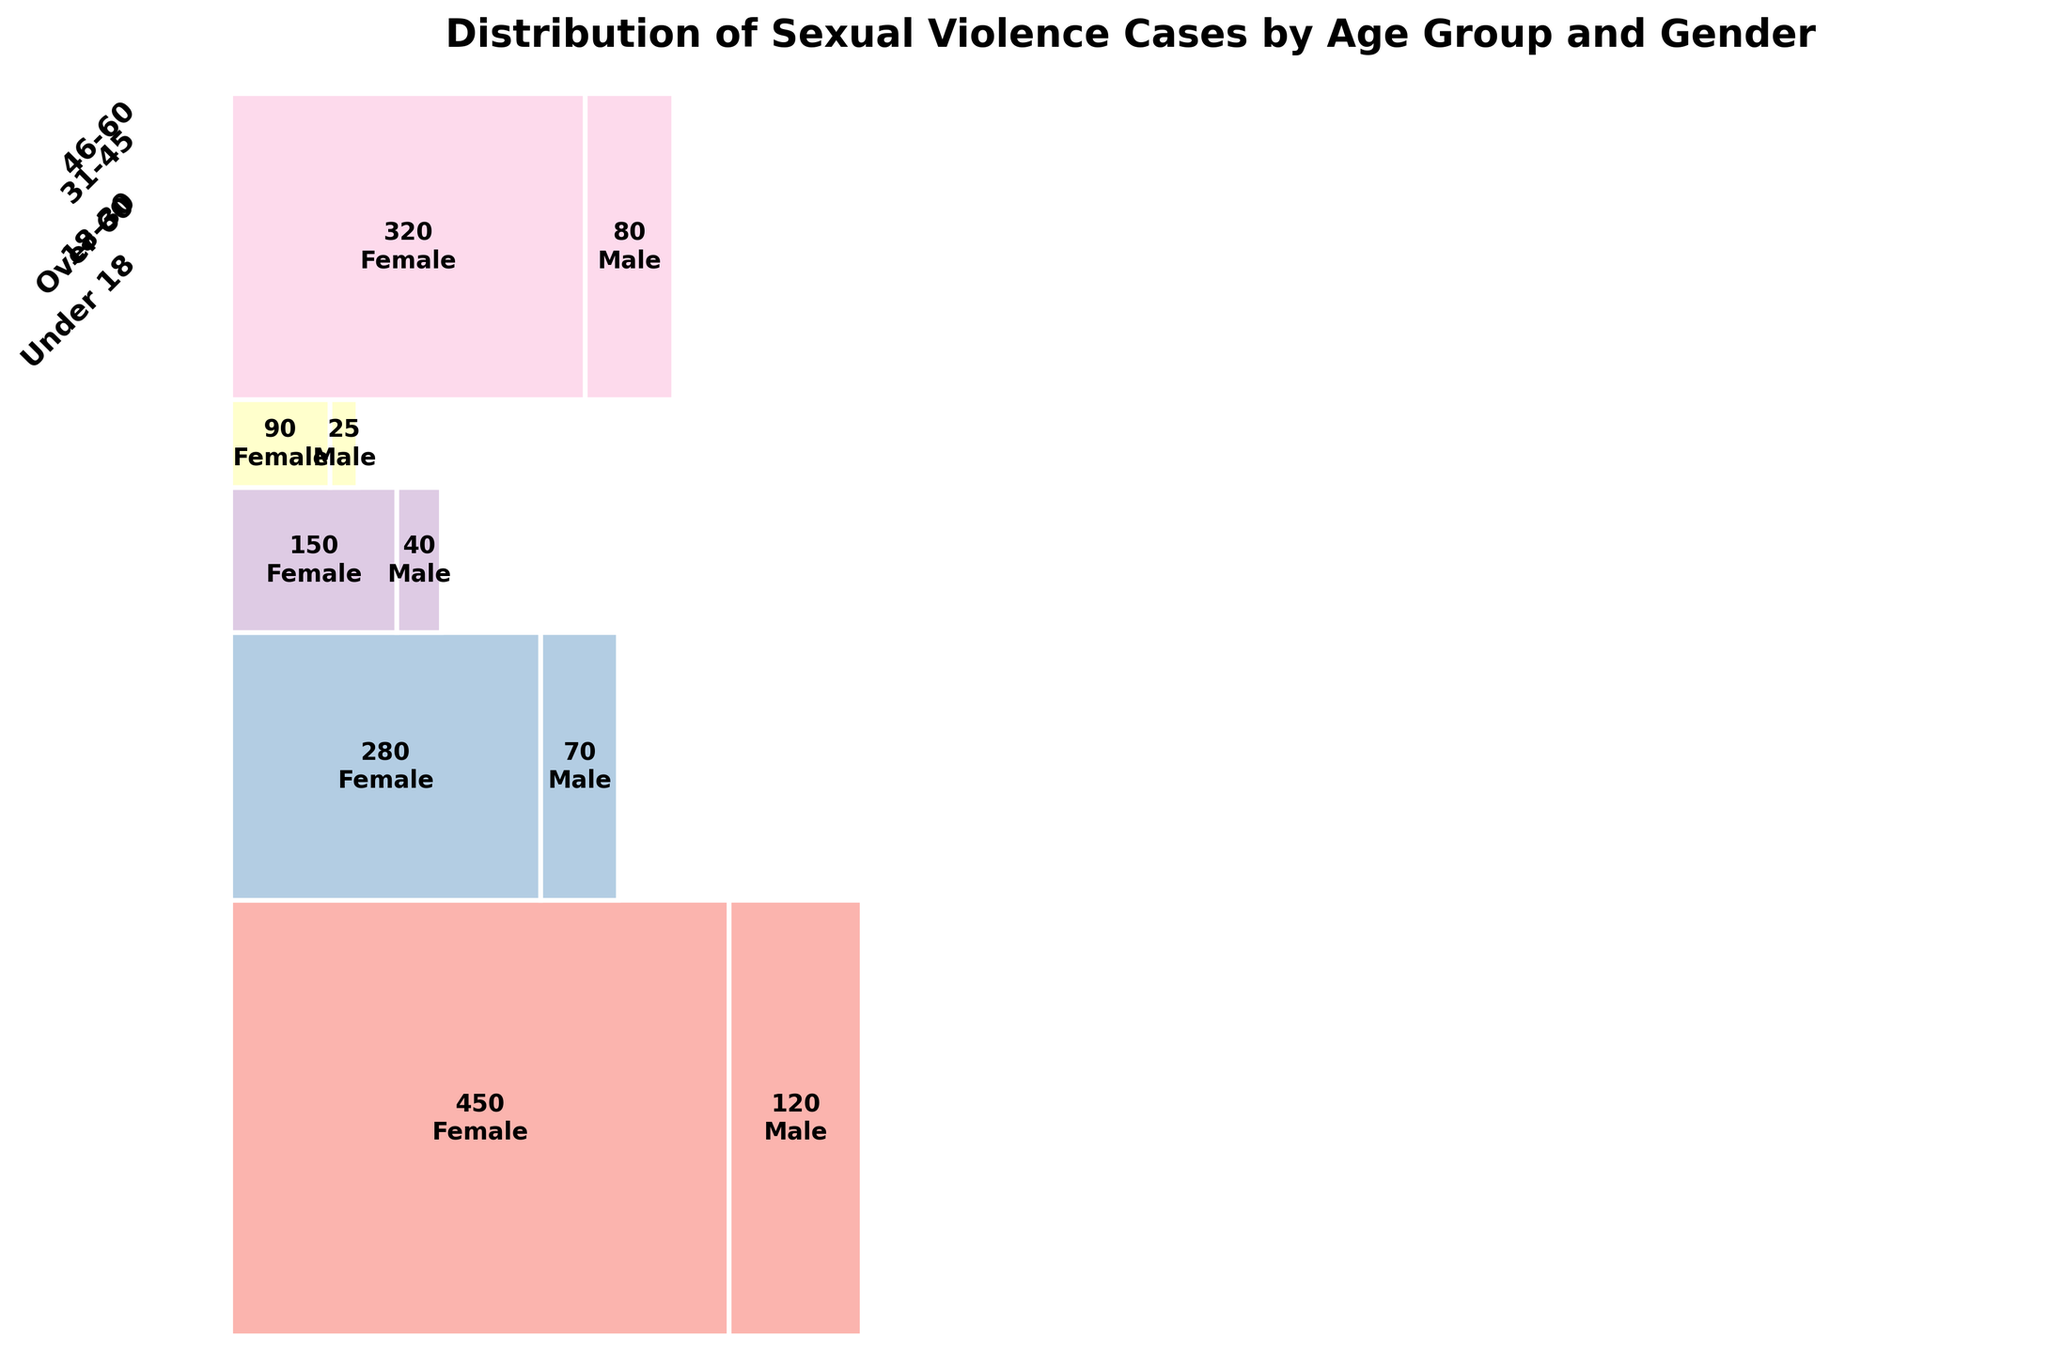What is the total number of cases involving females? Sum the number of cases for females across all age groups: 320 (Under 18) + 450 (18-30) + 280 (31-45) + 150 (46-60) + 90 (Over 60) = 1290
Answer: 1290 Which age group has the highest number of cases involving males? Compare the cases of males across all age groups: 80 (Under 18), 120 (18-30), 70 (31-45), 40 (46-60), 25 (Over 60). The highest number of cases for males is in the 18-30 age group with 120 cases.
Answer: 18-30 What is the proportion of cases involving females in the 18-30 age group relative to the total cases in that age group? Calculate the proportion using the formula: (number of female cases in 18-30 age group) / (total cases in 18-30 age group). This is 450 / (450 + 120) = 450 / 570 ≈ 0.789 or 78.9%
Answer: 78.9% How do the number of cases involving males in the 46-60 age group compare to those in the over 60 age group? Compare the number of male cases in both age groups: 40 (46-60) versus 25 (Over 60). There are more cases in the 46-60 age group (40 > 25).
Answer: 46-60 Which age group has the lowest total number of cases? Sum the cases for both genders in each age group and compare: Under 18 (320+80=400), 18-30 (450+120=570), 31-45 (280+70=350), 46-60 (150+40=190), Over 60 (90+25=115). The Over 60 age group has the lowest total number of cases.
Answer: Over 60 What is the overall distribution of cases by gender? Sum the total cases for males and females: Females (320 + 450 + 280 + 150 + 90 = 1290), Males (80 + 120 + 70 + 40 + 25 = 335), total cases = 1290 + 335 = 1625. Proportion of females is 1290 / 1625 ≈ 0.794 or 79.4%, and males is 335 / 1625 ≈ 0.206 or 20.6%
Answer: 79.4% females, 20.6% males Which age group shows the most significant difference in cases between females and males? Calculate the difference in cases between females and males for each age group: Under 18 (320 - 80 = 240), 18-30 (450 - 120 = 330), 31-45 (280 - 70 = 210), 46-60 (150 - 40 = 110), Over 60 (90 - 25 = 65). The 18-30 age group has the most significant difference with 330 more cases for females.
Answer: 18-30 Is there an age group where the distribution of cases between males and females is relatively equal? Compare the cases for each age group: None are exactly equal, but the closer differences are seen in the 46-60 (150 females vs 40 males) and Over 60 (90 females vs 25 males) groups. Both still show that females are more prevalent.
Answer: None 